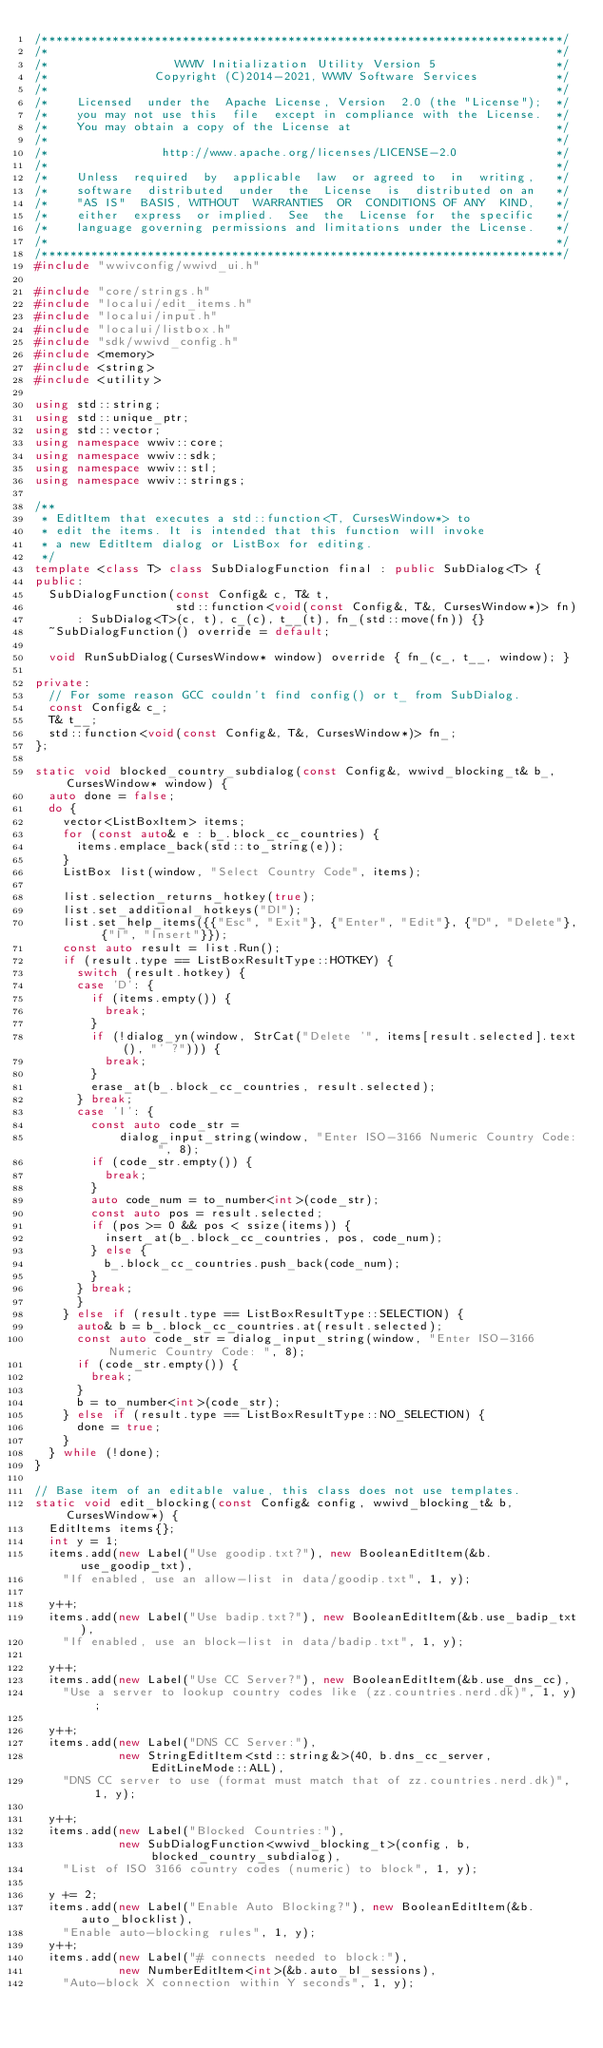<code> <loc_0><loc_0><loc_500><loc_500><_C++_>/**************************************************************************/
/*                                                                        */
/*                  WWIV Initialization Utility Version 5                 */
/*               Copyright (C)2014-2021, WWIV Software Services           */
/*                                                                        */
/*    Licensed  under the  Apache License, Version  2.0 (the "License");  */
/*    you may not use this  file  except in compliance with the License.  */
/*    You may obtain a copy of the License at                             */
/*                                                                        */
/*                http://www.apache.org/licenses/LICENSE-2.0              */
/*                                                                        */
/*    Unless  required  by  applicable  law  or agreed to  in  writing,   */
/*    software  distributed  under  the  License  is  distributed on an   */
/*    "AS IS"  BASIS, WITHOUT  WARRANTIES  OR  CONDITIONS OF ANY  KIND,   */
/*    either  express  or implied.  See  the  License for  the specific   */
/*    language governing permissions and limitations under the License.   */
/*                                                                        */
/**************************************************************************/
#include "wwivconfig/wwivd_ui.h"

#include "core/strings.h"
#include "localui/edit_items.h"
#include "localui/input.h"
#include "localui/listbox.h"
#include "sdk/wwivd_config.h"
#include <memory>
#include <string>
#include <utility>

using std::string;
using std::unique_ptr;
using std::vector;
using namespace wwiv::core;
using namespace wwiv::sdk;
using namespace wwiv::stl;
using namespace wwiv::strings;

/**
 * EditItem that executes a std::function<T, CursesWindow*> to
 * edit the items. It is intended that this function will invoke
 * a new EditItem dialog or ListBox for editing.
 */
template <class T> class SubDialogFunction final : public SubDialog<T> {
public:
  SubDialogFunction(const Config& c, T& t,
                    std::function<void(const Config&, T&, CursesWindow*)> fn)
      : SubDialog<T>(c, t), c_(c), t__(t), fn_(std::move(fn)) {}
  ~SubDialogFunction() override = default;

  void RunSubDialog(CursesWindow* window) override { fn_(c_, t__, window); }

private:
  // For some reason GCC couldn't find config() or t_ from SubDialog.
  const Config& c_;
  T& t__;
  std::function<void(const Config&, T&, CursesWindow*)> fn_;
};

static void blocked_country_subdialog(const Config&, wwivd_blocking_t& b_, CursesWindow* window) {
  auto done = false;
  do {
    vector<ListBoxItem> items;
    for (const auto& e : b_.block_cc_countries) {
      items.emplace_back(std::to_string(e));
    }
    ListBox list(window, "Select Country Code", items);

    list.selection_returns_hotkey(true);
    list.set_additional_hotkeys("DI");
    list.set_help_items({{"Esc", "Exit"}, {"Enter", "Edit"}, {"D", "Delete"}, {"I", "Insert"}});
    const auto result = list.Run();
    if (result.type == ListBoxResultType::HOTKEY) {
      switch (result.hotkey) {
      case 'D': {
        if (items.empty()) {
          break;
        }
        if (!dialog_yn(window, StrCat("Delete '", items[result.selected].text(), "' ?"))) {
          break;
        }
        erase_at(b_.block_cc_countries, result.selected);
      } break;
      case 'I': {
        const auto code_str =
            dialog_input_string(window, "Enter ISO-3166 Numeric Country Code: ", 8);
        if (code_str.empty()) {
          break;
        }
        auto code_num = to_number<int>(code_str);
        const auto pos = result.selected;
        if (pos >= 0 && pos < ssize(items)) {
          insert_at(b_.block_cc_countries, pos, code_num);
        } else {
          b_.block_cc_countries.push_back(code_num);
        }
      } break;
      }
    } else if (result.type == ListBoxResultType::SELECTION) {
      auto& b = b_.block_cc_countries.at(result.selected);
      const auto code_str = dialog_input_string(window, "Enter ISO-3166 Numeric Country Code: ", 8);
      if (code_str.empty()) {
        break;
      }
      b = to_number<int>(code_str);
    } else if (result.type == ListBoxResultType::NO_SELECTION) {
      done = true;
    }
  } while (!done);
}

// Base item of an editable value, this class does not use templates.
static void edit_blocking(const Config& config, wwivd_blocking_t& b, CursesWindow*) {
  EditItems items{};
  int y = 1;
  items.add(new Label("Use goodip.txt?"), new BooleanEditItem(&b.use_goodip_txt), 
    "If enabled, use an allow-list in data/goodip.txt", 1, y);

  y++;
  items.add(new Label("Use badip.txt?"), new BooleanEditItem(&b.use_badip_txt), 
    "If enabled, use an block-list in data/badip.txt", 1, y);

  y++;
  items.add(new Label("Use CC Server?"), new BooleanEditItem(&b.use_dns_cc), 
    "Use a server to lookup country codes like (zz.countries.nerd.dk)", 1, y);

  y++;
  items.add(new Label("DNS CC Server:"),
            new StringEditItem<std::string&>(40, b.dns_cc_server, EditLineMode::ALL), 
    "DNS CC server to use (format must match that of zz.countries.nerd.dk)", 1, y);

  y++;
  items.add(new Label("Blocked Countries:"),
            new SubDialogFunction<wwivd_blocking_t>(config, b, blocked_country_subdialog), 
    "List of ISO 3166 country codes (numeric) to block", 1, y);

  y += 2;
  items.add(new Label("Enable Auto Blocking?"), new BooleanEditItem(&b.auto_blocklist), 
    "Enable auto-blocking rules", 1, y);
  y++;
  items.add(new Label("# connects needed to block:"),
            new NumberEditItem<int>(&b.auto_bl_sessions), 
    "Auto-block X connection within Y seconds", 1, y);</code> 